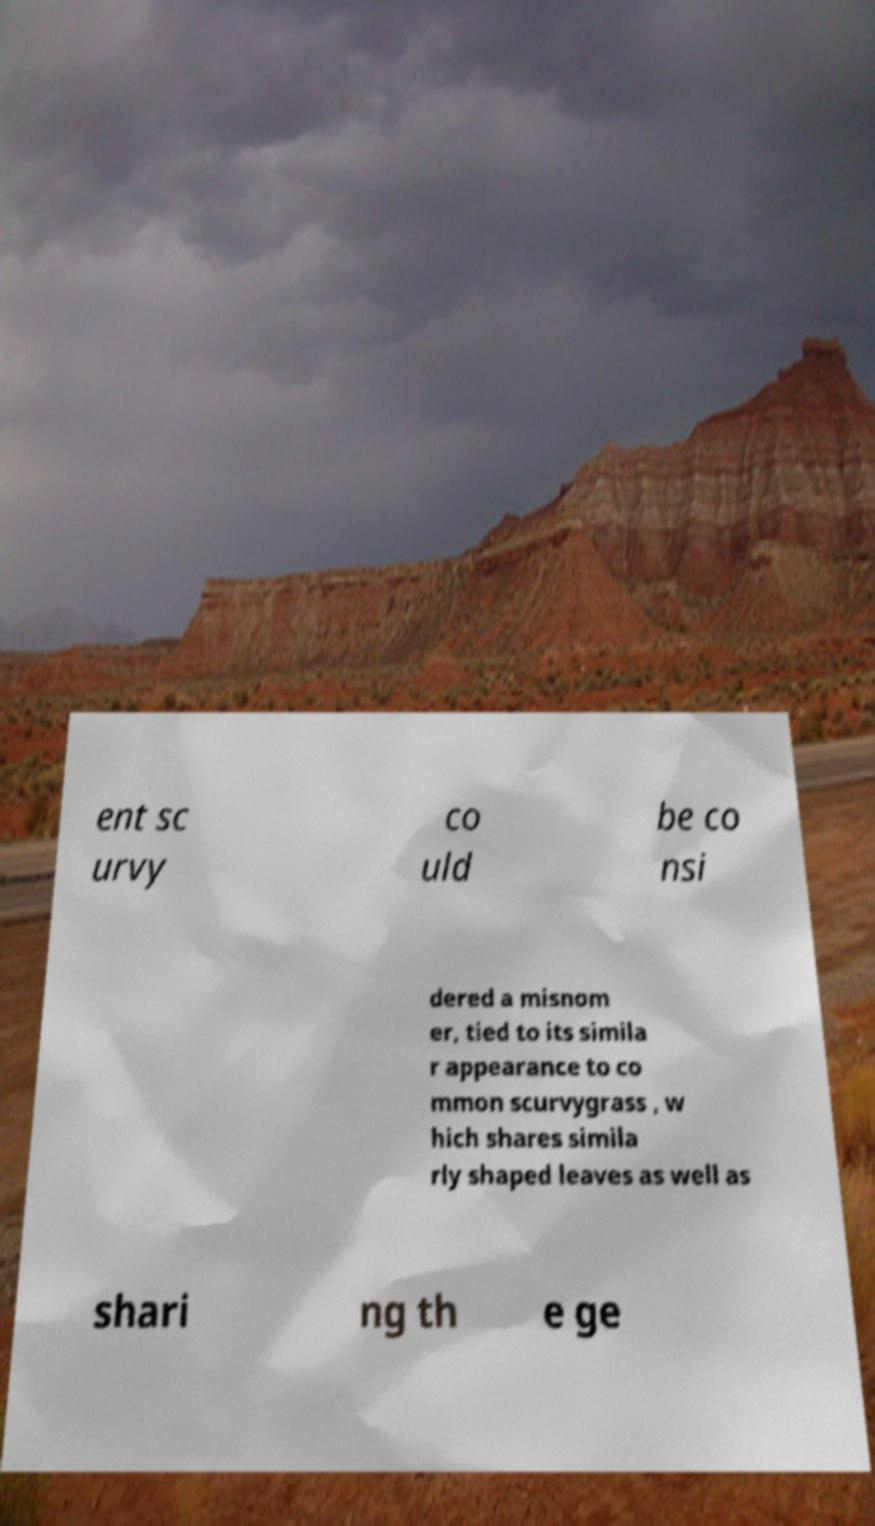Can you accurately transcribe the text from the provided image for me? ent sc urvy co uld be co nsi dered a misnom er, tied to its simila r appearance to co mmon scurvygrass , w hich shares simila rly shaped leaves as well as shari ng th e ge 